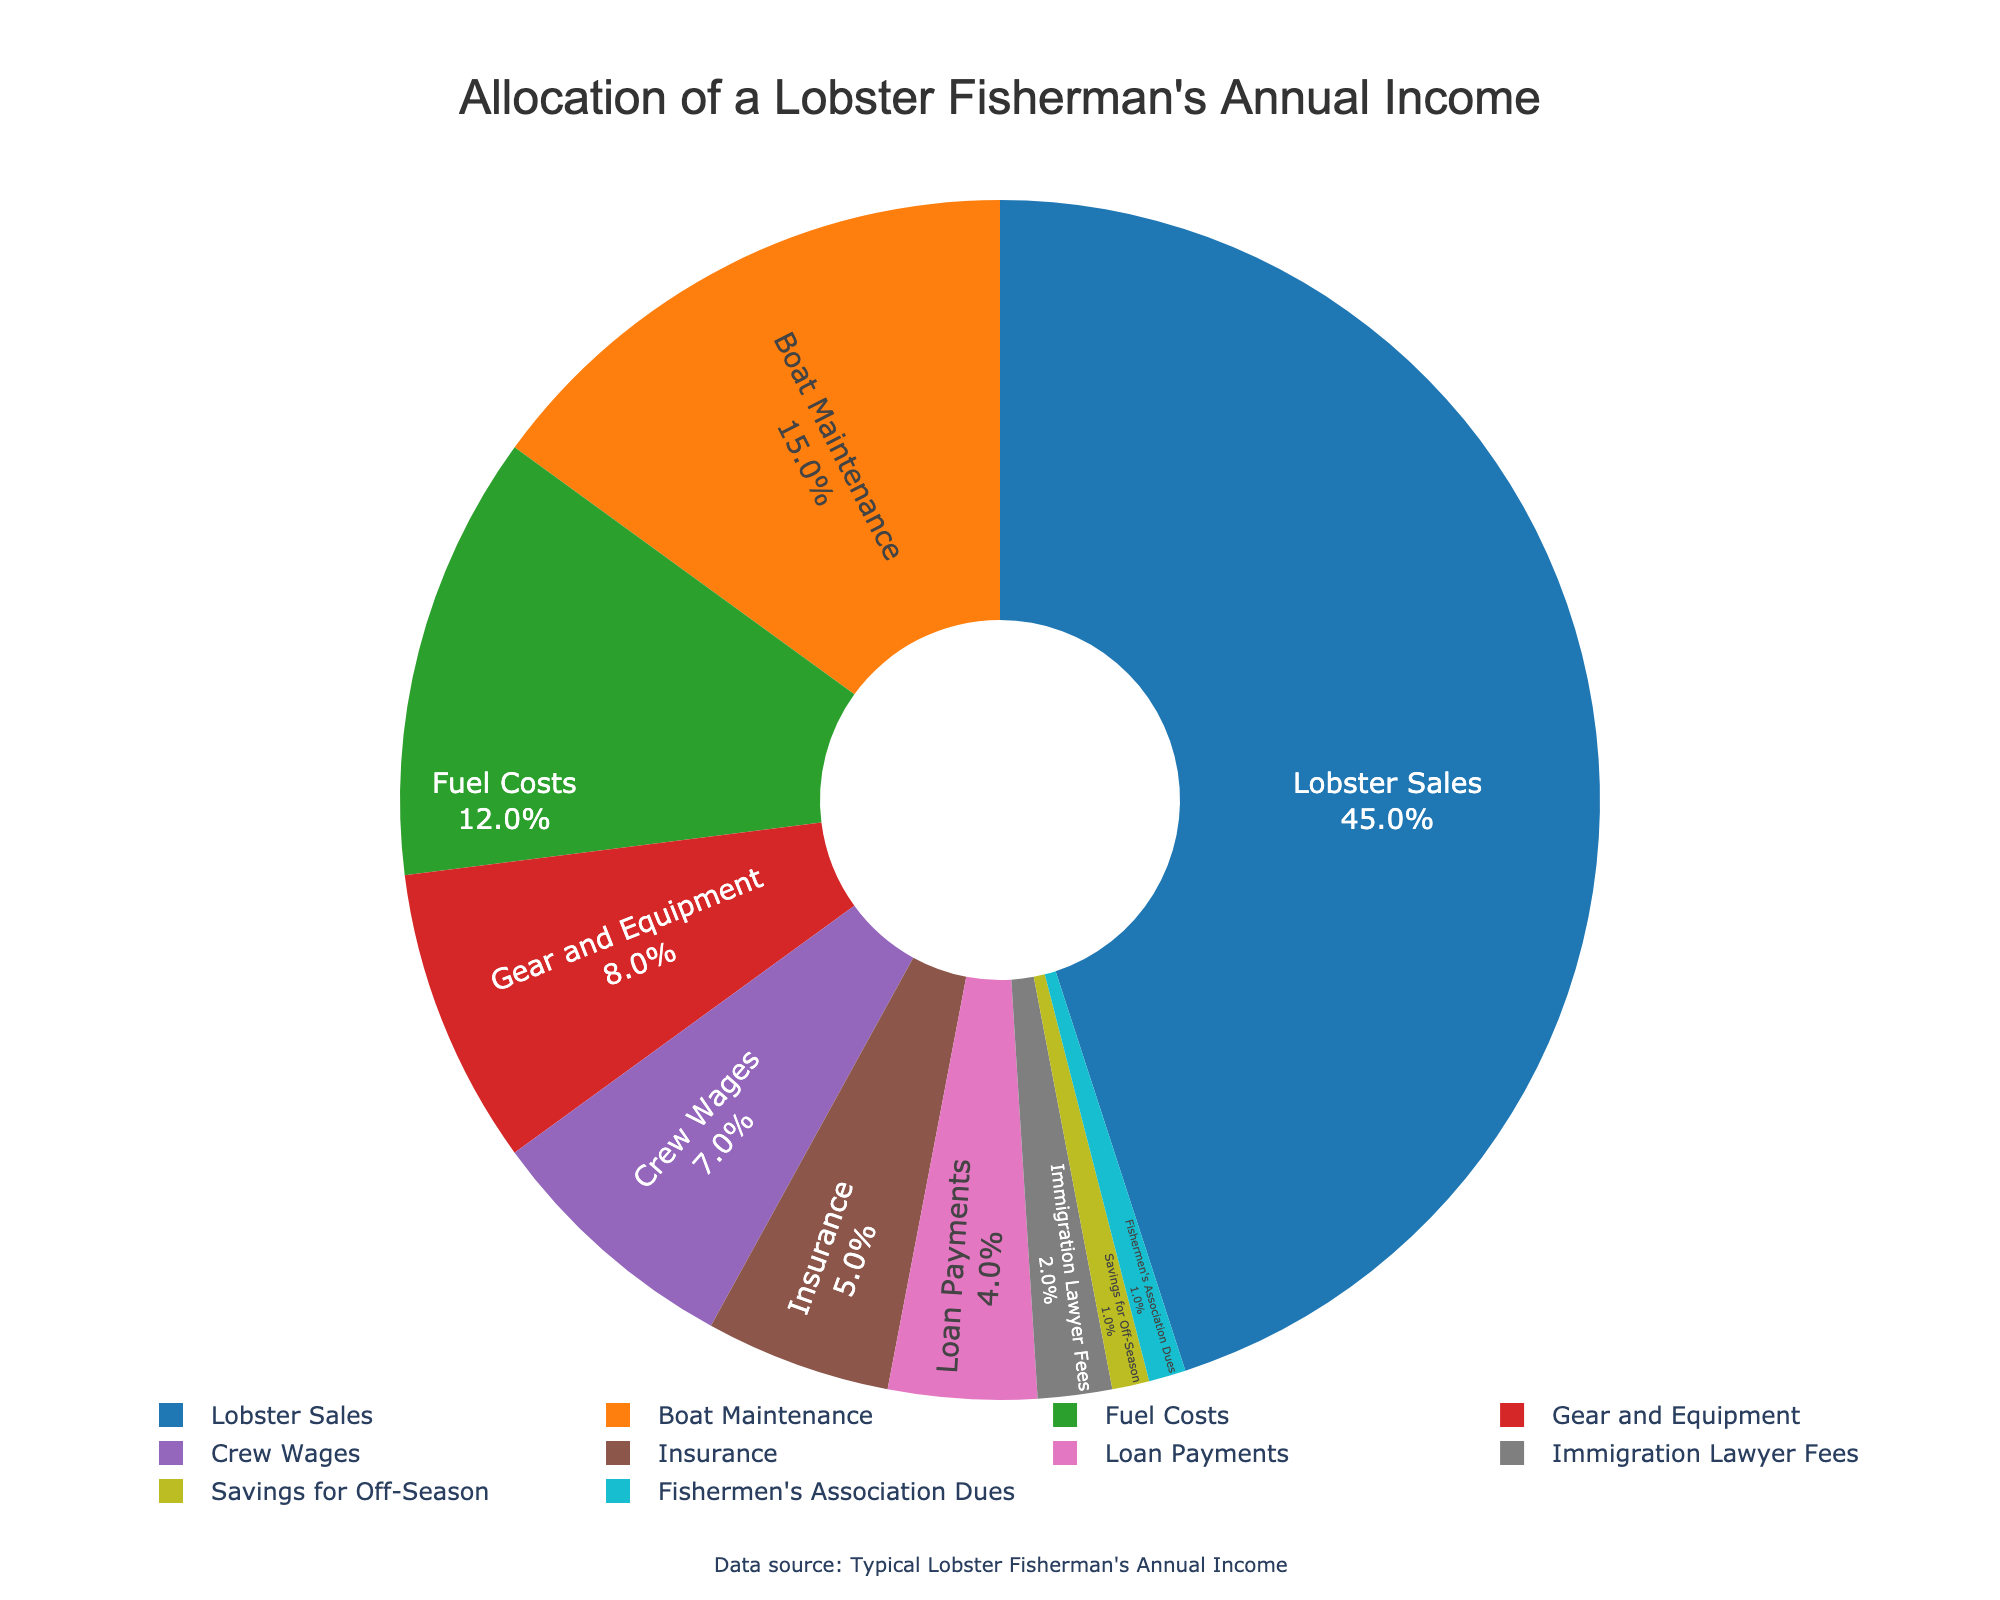What is the largest allocation category in the pie chart? By looking at the pie chart, the largest segment is easily identifiable as "Lobster Sales". Its percentage is the highest at 45%.
Answer: Lobster Sales What percentage of income is allocated to both Boat Maintenance and Crew Wages combined? The pie chart shows Boat Maintenance at 15% and Crew Wages at 7%. Adding them together gives 15 + 7 = 22%.
Answer: 22% Which category uses more income: Fuel Costs or Gear and Equipment? The pie chart shows Fuel Costs at 12% and Gear and Equipment at 8%. Since 12% is more than 8%, Fuel Costs use more income.
Answer: Fuel Costs Is the sum of Insurance and Loan Payments greater than Boat Maintenance alone? Insurance is 5% and Loan Payments are 4%, so their sum is 5 + 4 = 9%. Boat Maintenance is 15%, which is greater than 9%, so the sum is not greater.
Answer: No How much higher is the percentage allocated to Lobster Sales compared to Fuel Costs? Lobster Sales is 45% and Fuel Costs are 12%. The difference is 45 - 12 = 33%.
Answer: 33% What are the two smallest categories, and what is their combined percentage? The two smallest categories are Savings for Off-Season and Fishermen's Association Dues at 1% each. Their combined percentage is 1 + 1 = 2%.
Answer: Savings for Off-Season and Fishermen's Association Dues; 2% Which category has a greater percentage: Boat Maintenance or the combined total of Immigrant Lawyer Fees and Loan Payments? Boat Maintenance is at 15%. Immigrant Lawyer Fees are 2% and Loan Payments are 4%, so their combined total is 2 + 4 = 6%. Since 15% is greater than 6%, Boat Maintenance has a greater percentage.
Answer: Boat Maintenance What is the second largest category in the pie chart? The second largest category is identifiable as Boat Maintenance, which has the second highest percentage at 15%.
Answer: Boat Maintenance 